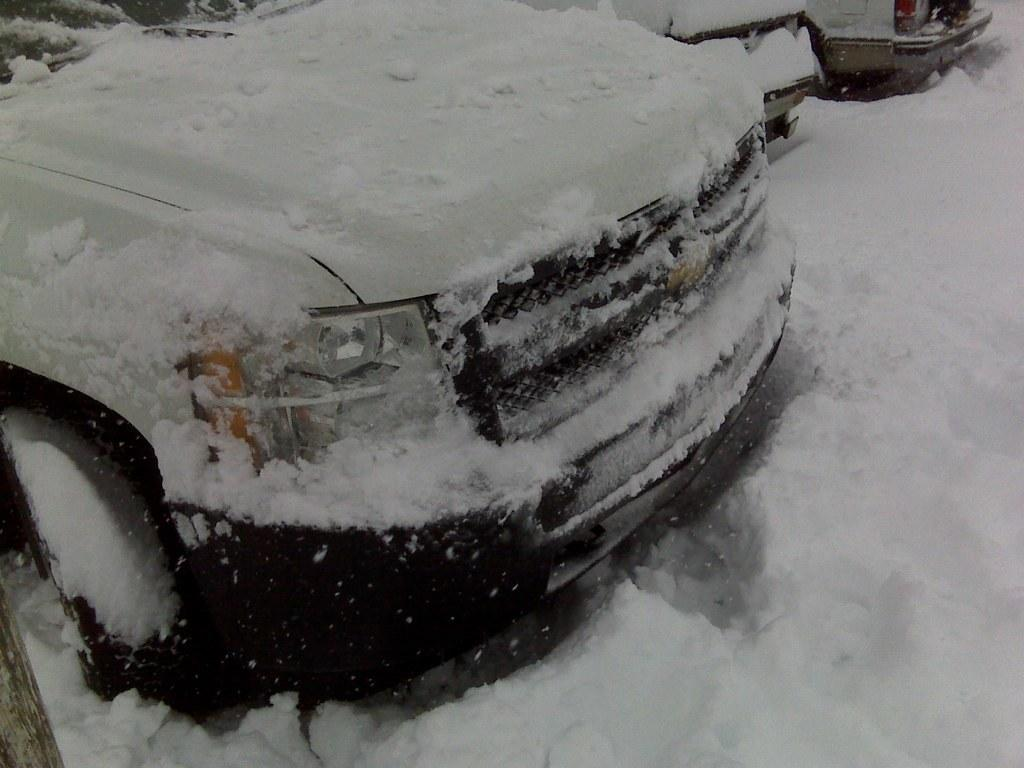What type of vehicles are on the left side of the image? There are cars on the left side of the image. What is covering the cars in the image? There is ice on the cars. Can you describe the bottom part of the image? There is ice at the bottom of the image. What type of unit is being measured in the image? There is no indication of any unit being measured in the image. Can you see a toothbrush in the image? No, there is no toothbrush present in the image. 